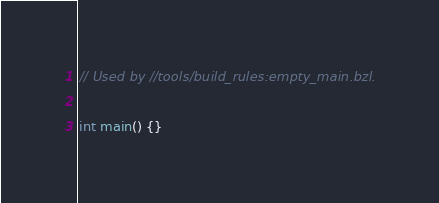Convert code to text. <code><loc_0><loc_0><loc_500><loc_500><_C_>// Used by //tools/build_rules:empty_main.bzl.

int main() {}
</code> 